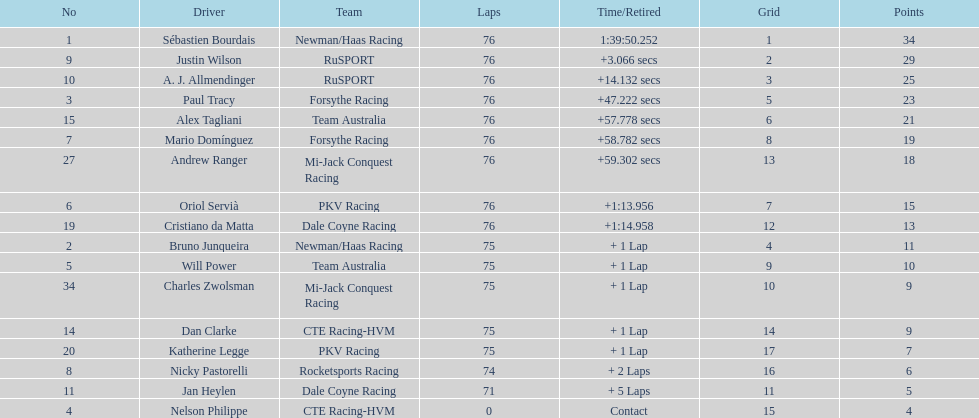How many points did charles zwolsman acquire? 9. Who else got 9 points? Dan Clarke. 